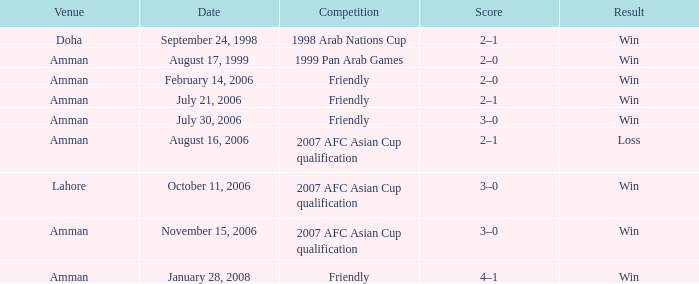What was the score of the friendly match at Amman on February 14, 2006? 2–0. 